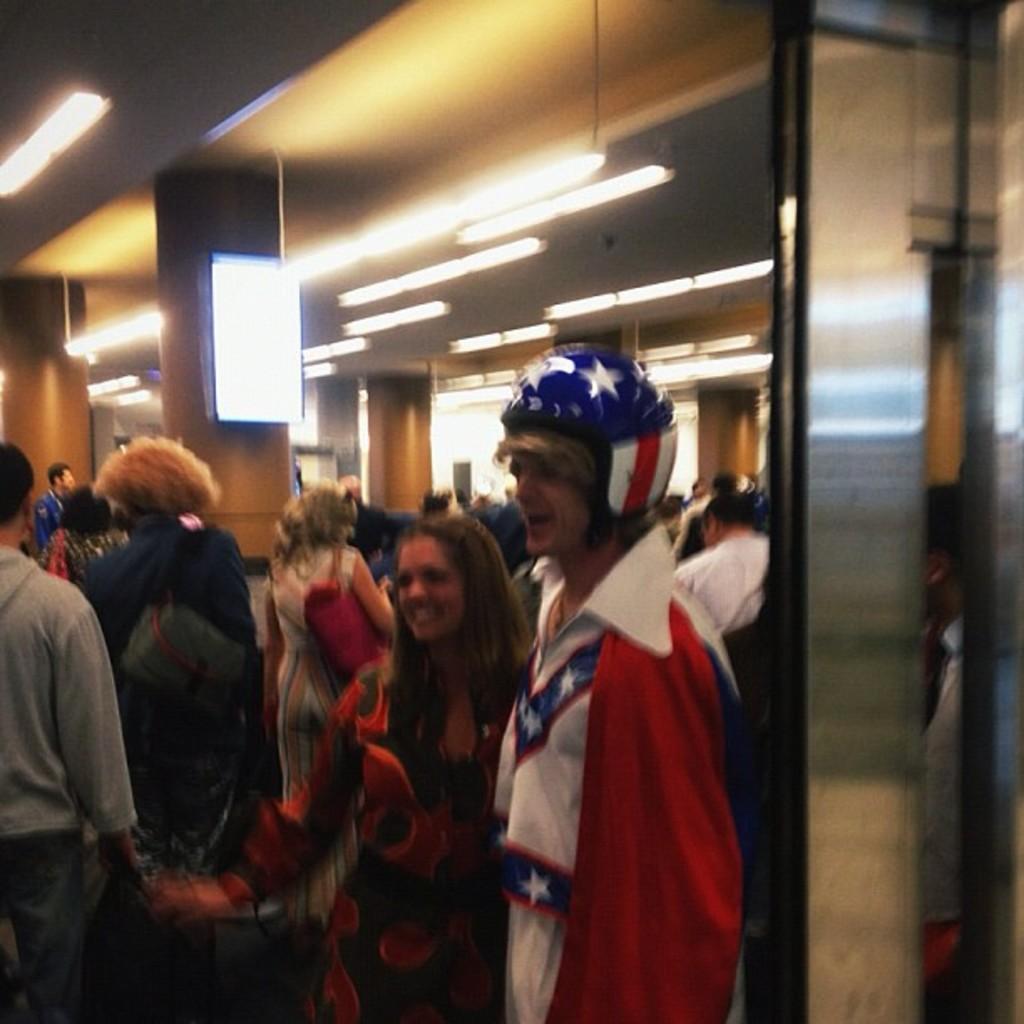Describe this image in one or two sentences. This image is inside of a building, there are few men and women in the building, there is a display board on a pillar, on top of the ceiling there are lights. 